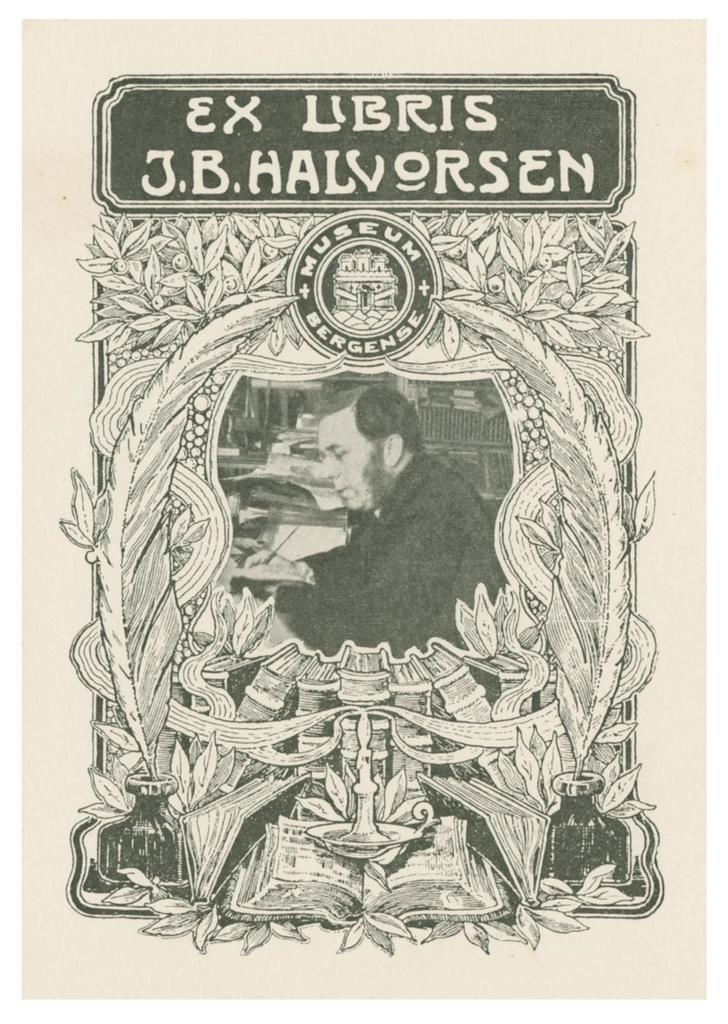What is the first word written on the top left?
Your answer should be compact. Ex. 